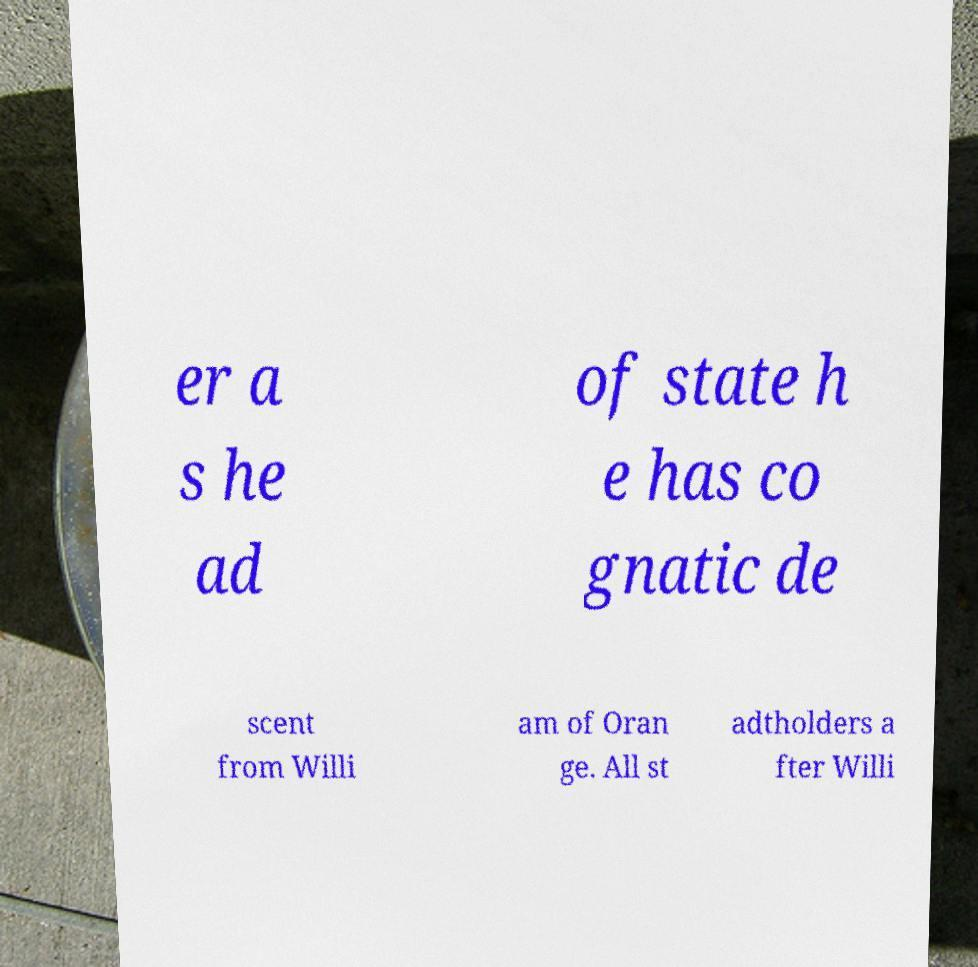There's text embedded in this image that I need extracted. Can you transcribe it verbatim? er a s he ad of state h e has co gnatic de scent from Willi am of Oran ge. All st adtholders a fter Willi 